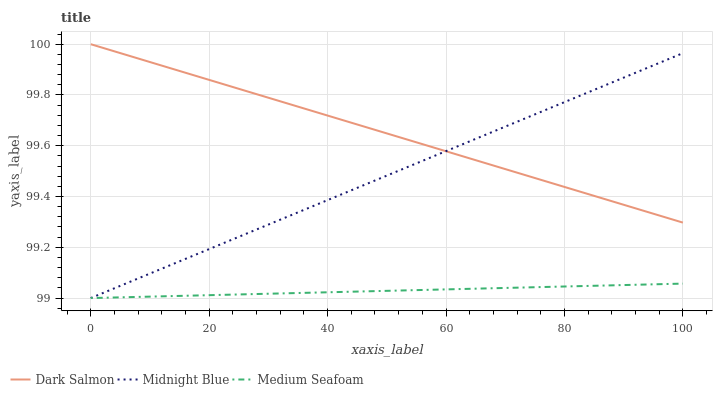Does Medium Seafoam have the minimum area under the curve?
Answer yes or no. Yes. Does Dark Salmon have the maximum area under the curve?
Answer yes or no. Yes. Does Midnight Blue have the minimum area under the curve?
Answer yes or no. No. Does Midnight Blue have the maximum area under the curve?
Answer yes or no. No. Is Dark Salmon the smoothest?
Answer yes or no. Yes. Is Medium Seafoam the roughest?
Answer yes or no. Yes. Is Midnight Blue the smoothest?
Answer yes or no. No. Is Midnight Blue the roughest?
Answer yes or no. No. Does Medium Seafoam have the lowest value?
Answer yes or no. Yes. Does Dark Salmon have the lowest value?
Answer yes or no. No. Does Dark Salmon have the highest value?
Answer yes or no. Yes. Does Midnight Blue have the highest value?
Answer yes or no. No. Is Medium Seafoam less than Dark Salmon?
Answer yes or no. Yes. Is Dark Salmon greater than Medium Seafoam?
Answer yes or no. Yes. Does Dark Salmon intersect Midnight Blue?
Answer yes or no. Yes. Is Dark Salmon less than Midnight Blue?
Answer yes or no. No. Is Dark Salmon greater than Midnight Blue?
Answer yes or no. No. Does Medium Seafoam intersect Dark Salmon?
Answer yes or no. No. 